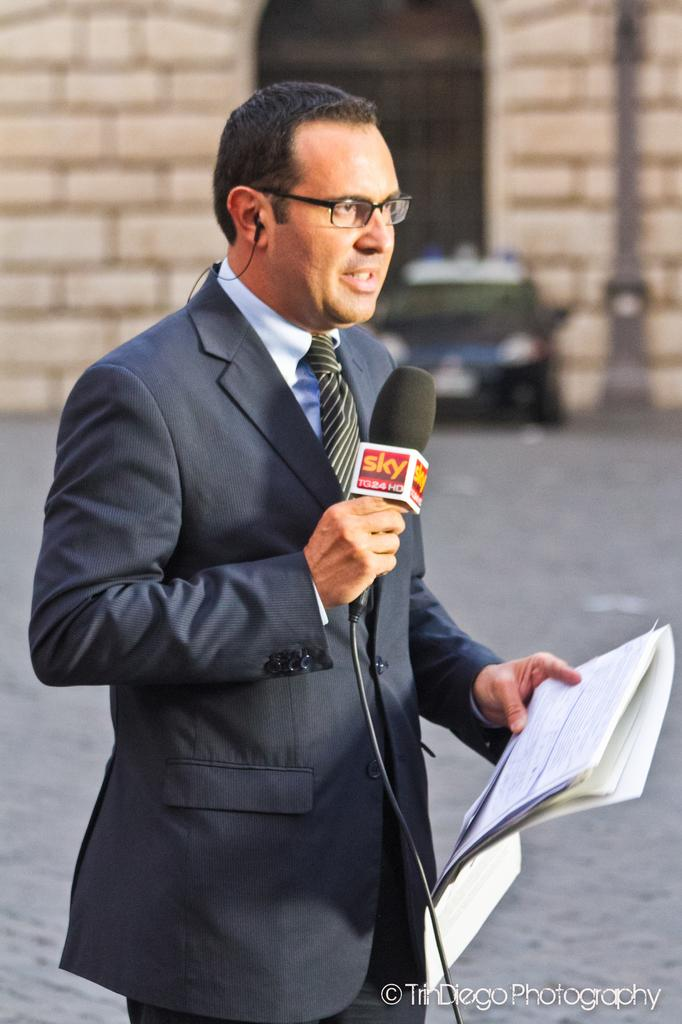What is the man in the image holding in one hand? The man is holding papers in one hand. What is the man holding in his other hand? The man is holding a microphone in his other hand. What can be seen in the background of the image? There is a car, a building, a door, and a pole in the background of the image. What type of expert can be seen laughing and beaming in the image? There is no expert, laughter, or beaming present in the image. 